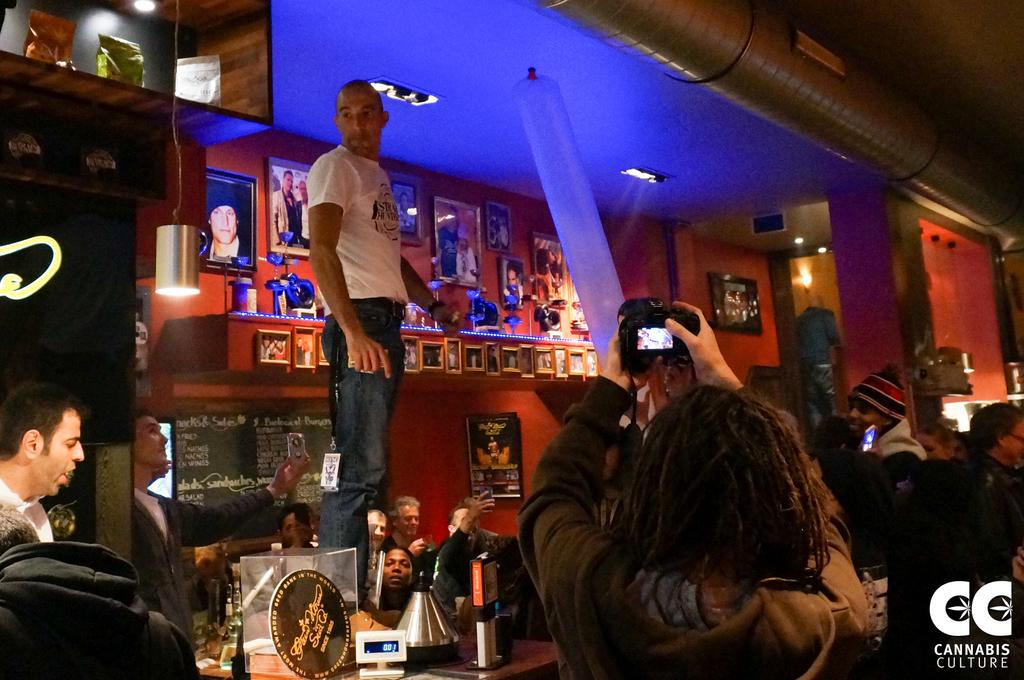What is located in the foreground of the image? There are people in the foreground of the image. What can be seen in the background of the image? There are frames, a light, a person standing on a table, and other objects in the background of the image. Can you describe the light in the background of the image? Unfortunately, the facts provided do not give any details about the light, so we cannot describe it further. How many jellyfish are swimming in the background of the image? There are no jellyfish present in the image. Is there a stranger standing next to the person on the table in the background of the image? The facts provided do not mention any strangers in the image, so we cannot confirm or deny their presence. 